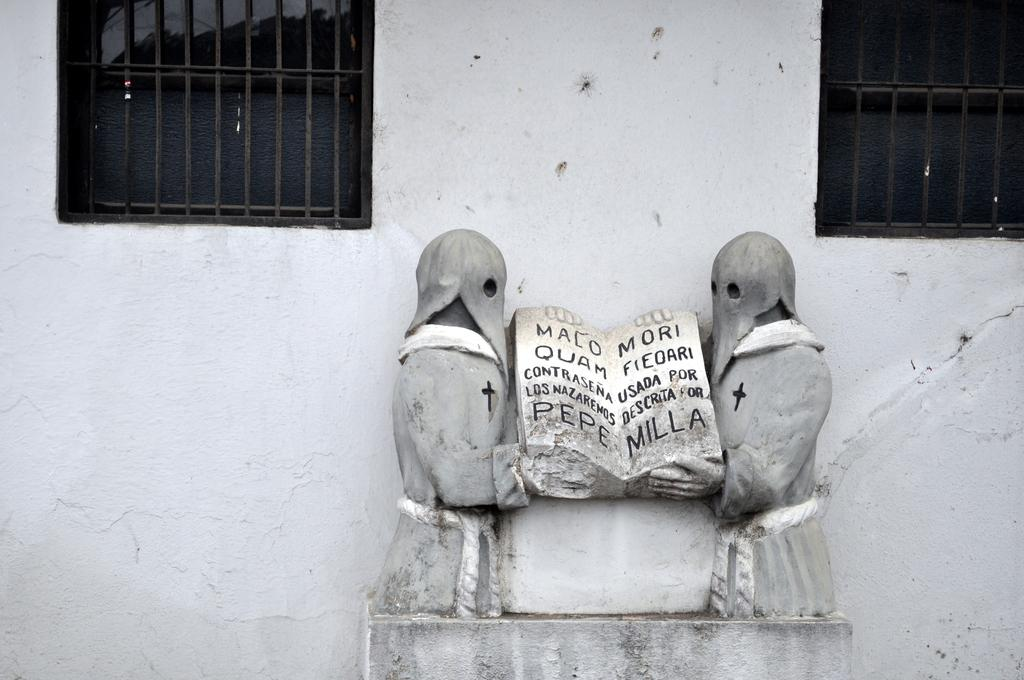What type of art is present in the image? There are sculptures in the image. What architectural feature can be seen on the wall in the image? There are windows with grill rods on the wall in the image. What type of ship is visible in the image? There is no ship present in the image. What advice is being given in the image? There is no advice being given in the image; it only features sculptures and windows with grill rods. 